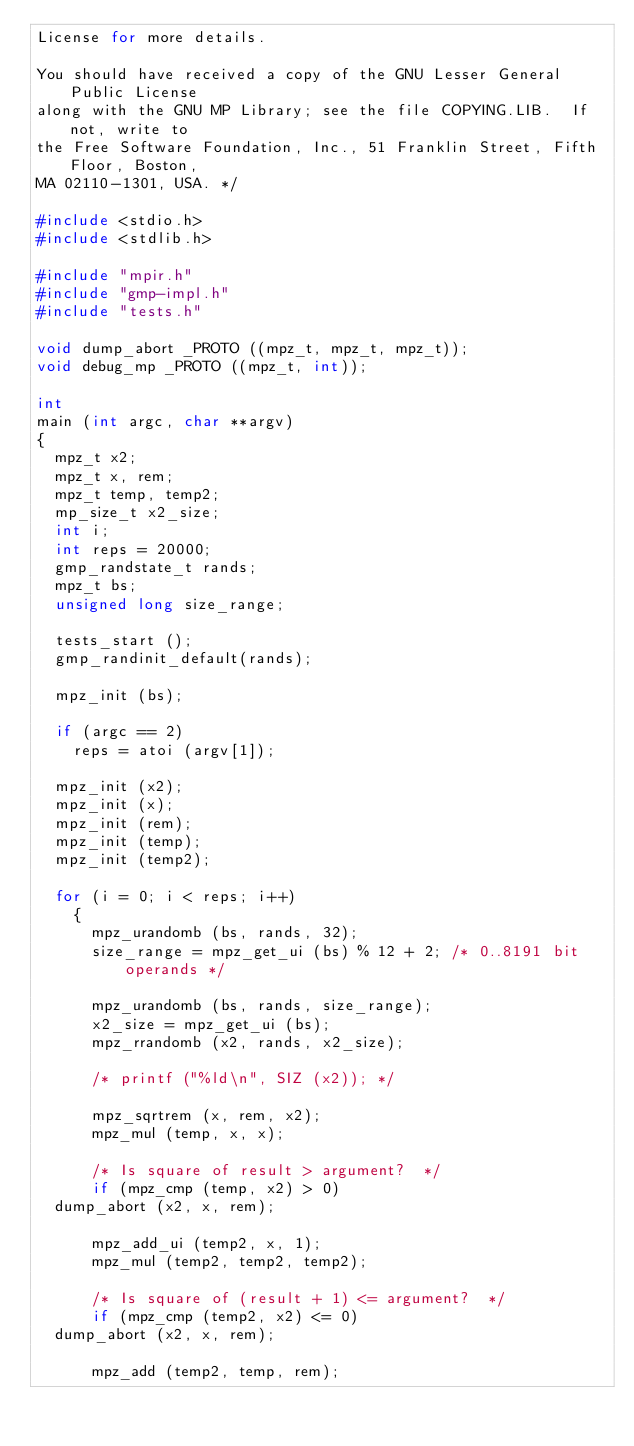<code> <loc_0><loc_0><loc_500><loc_500><_C_>License for more details.

You should have received a copy of the GNU Lesser General Public License
along with the GNU MP Library; see the file COPYING.LIB.  If not, write to
the Free Software Foundation, Inc., 51 Franklin Street, Fifth Floor, Boston,
MA 02110-1301, USA. */

#include <stdio.h>
#include <stdlib.h>

#include "mpir.h"
#include "gmp-impl.h"
#include "tests.h"

void dump_abort _PROTO ((mpz_t, mpz_t, mpz_t));
void debug_mp _PROTO ((mpz_t, int));

int
main (int argc, char **argv)
{
  mpz_t x2;
  mpz_t x, rem;
  mpz_t temp, temp2;
  mp_size_t x2_size;
  int i;
  int reps = 20000;
  gmp_randstate_t rands;
  mpz_t bs;
  unsigned long size_range;

  tests_start ();
  gmp_randinit_default(rands);

  mpz_init (bs);

  if (argc == 2)
    reps = atoi (argv[1]);

  mpz_init (x2);
  mpz_init (x);
  mpz_init (rem);
  mpz_init (temp);
  mpz_init (temp2);

  for (i = 0; i < reps; i++)
    {
      mpz_urandomb (bs, rands, 32);
      size_range = mpz_get_ui (bs) % 12 + 2; /* 0..8191 bit operands */

      mpz_urandomb (bs, rands, size_range);
      x2_size = mpz_get_ui (bs);
      mpz_rrandomb (x2, rands, x2_size);

      /* printf ("%ld\n", SIZ (x2)); */

      mpz_sqrtrem (x, rem, x2);
      mpz_mul (temp, x, x);

      /* Is square of result > argument?  */
      if (mpz_cmp (temp, x2) > 0)
	dump_abort (x2, x, rem);

      mpz_add_ui (temp2, x, 1);
      mpz_mul (temp2, temp2, temp2);

      /* Is square of (result + 1) <= argument?  */
      if (mpz_cmp (temp2, x2) <= 0)
	dump_abort (x2, x, rem);

      mpz_add (temp2, temp, rem);
</code> 